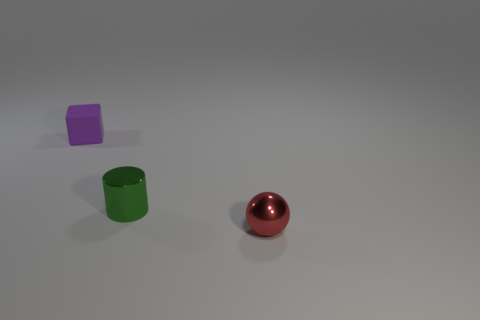What number of things are there?
Your response must be concise. 3. Does the small thing behind the green shiny thing have the same material as the tiny sphere?
Provide a succinct answer. No. There is a thing that is both in front of the tiny purple matte block and behind the tiny red sphere; what material is it?
Your answer should be very brief. Metal. What is the material of the thing in front of the metal thing that is behind the tiny red thing?
Offer a terse response. Metal. How many spheres are the same material as the tiny red thing?
Keep it short and to the point. 0. There is a small metal object to the left of the metal thing that is in front of the green cylinder; what is its color?
Your answer should be compact. Green. What number of things are big rubber cubes or tiny objects in front of the small purple thing?
Offer a very short reply. 2. Are there any rubber things of the same color as the block?
Offer a terse response. No. What number of green things are metal spheres or small metallic cylinders?
Offer a very short reply. 1. How many other things are there of the same size as the ball?
Your answer should be very brief. 2. 